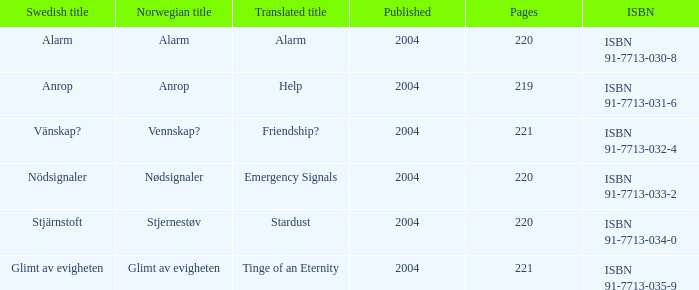How many pages associated with isbn 91-7713-035-9? 221.0. 